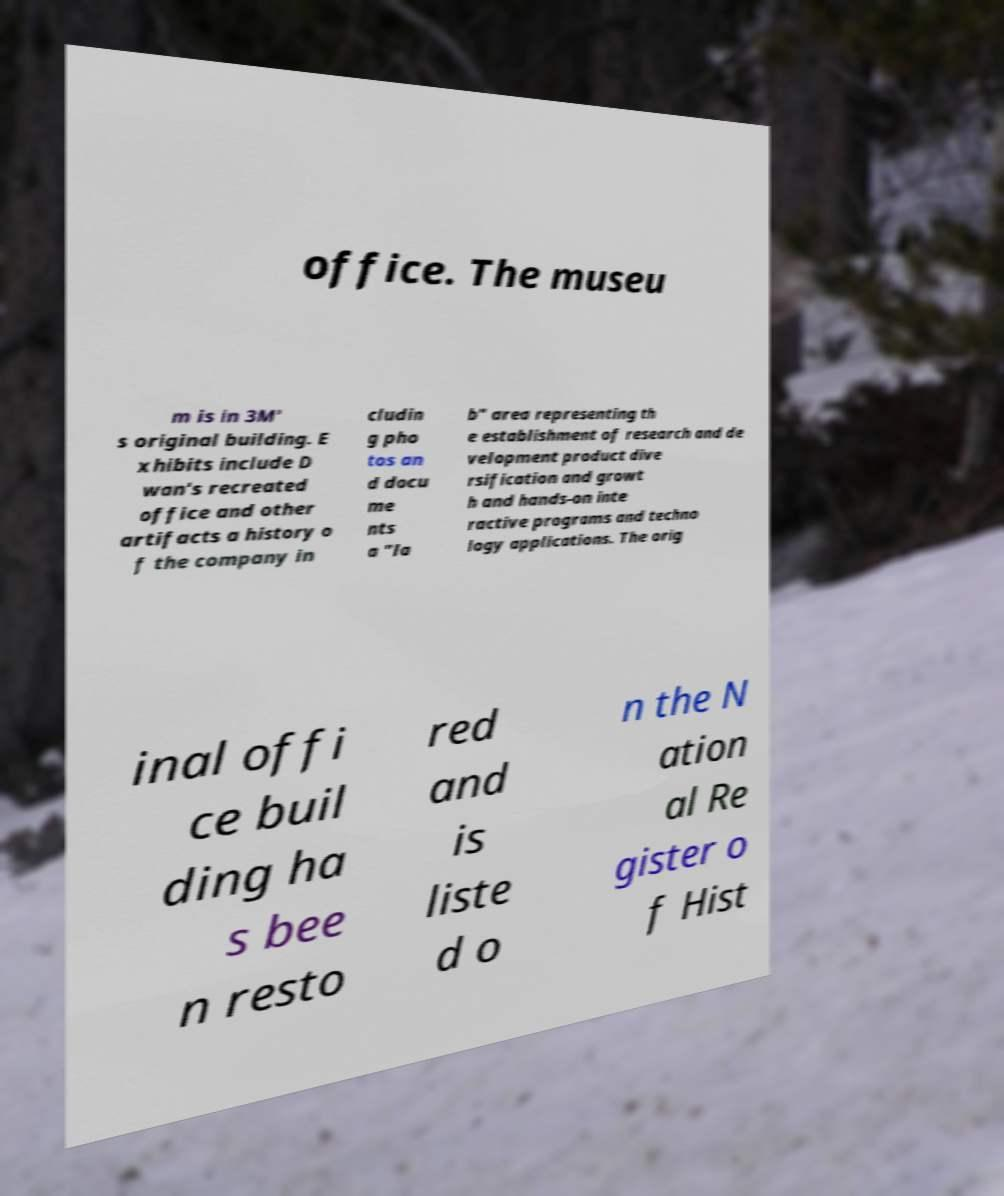What messages or text are displayed in this image? I need them in a readable, typed format. office. The museu m is in 3M' s original building. E xhibits include D wan's recreated office and other artifacts a history o f the company in cludin g pho tos an d docu me nts a "la b" area representing th e establishment of research and de velopment product dive rsification and growt h and hands-on inte ractive programs and techno logy applications. The orig inal offi ce buil ding ha s bee n resto red and is liste d o n the N ation al Re gister o f Hist 